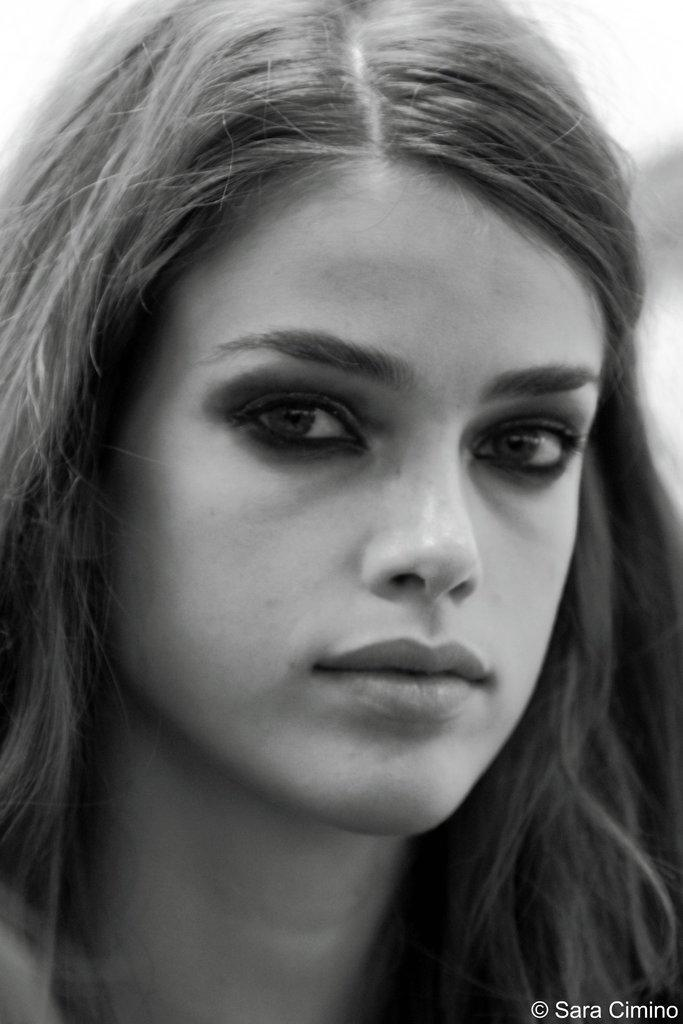What is the main subject of the image? There is a woman's face in the image. Are there any additional elements in the image besides the woman's face? Yes, there is a watermark in the image. What is the color scheme of the image? The image is black and white. Can you tell me what the woman's face looks like during the argument in the image? There is no argument depicted in the image, and the woman's face is the only subject present. How does the dust accumulate on the woman's face in the image? There is no dust present in the image, as it is a black and white photograph of a woman's face. 